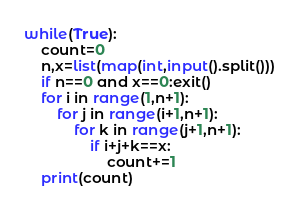<code> <loc_0><loc_0><loc_500><loc_500><_Python_>while(True):
    count=0
    n,x=list(map(int,input().split()))
    if n==0 and x==0:exit()
    for i in range(1,n+1):
        for j in range(i+1,n+1):
            for k in range(j+1,n+1):
                if i+j+k==x:
                    count+=1
    print(count)
</code> 